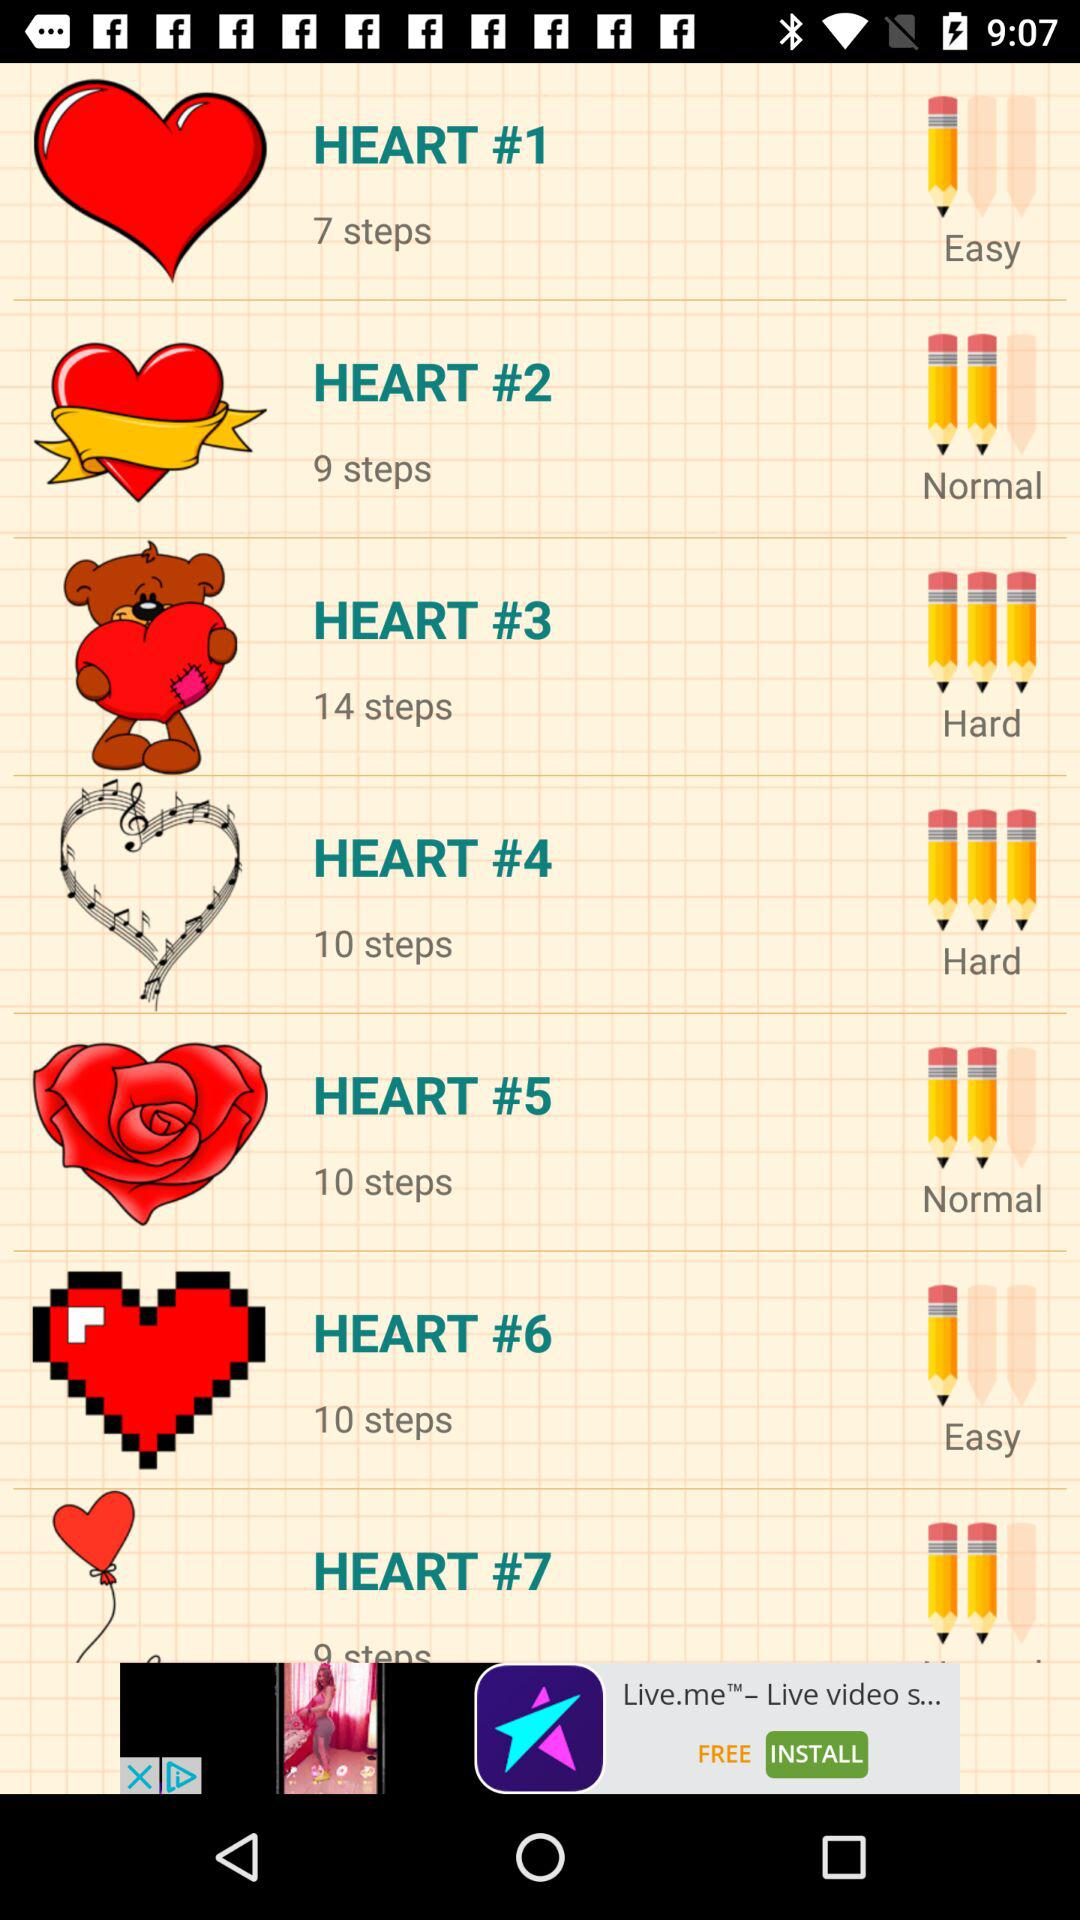How many steps are there in the "HEART #2"? There are 9 steps. 